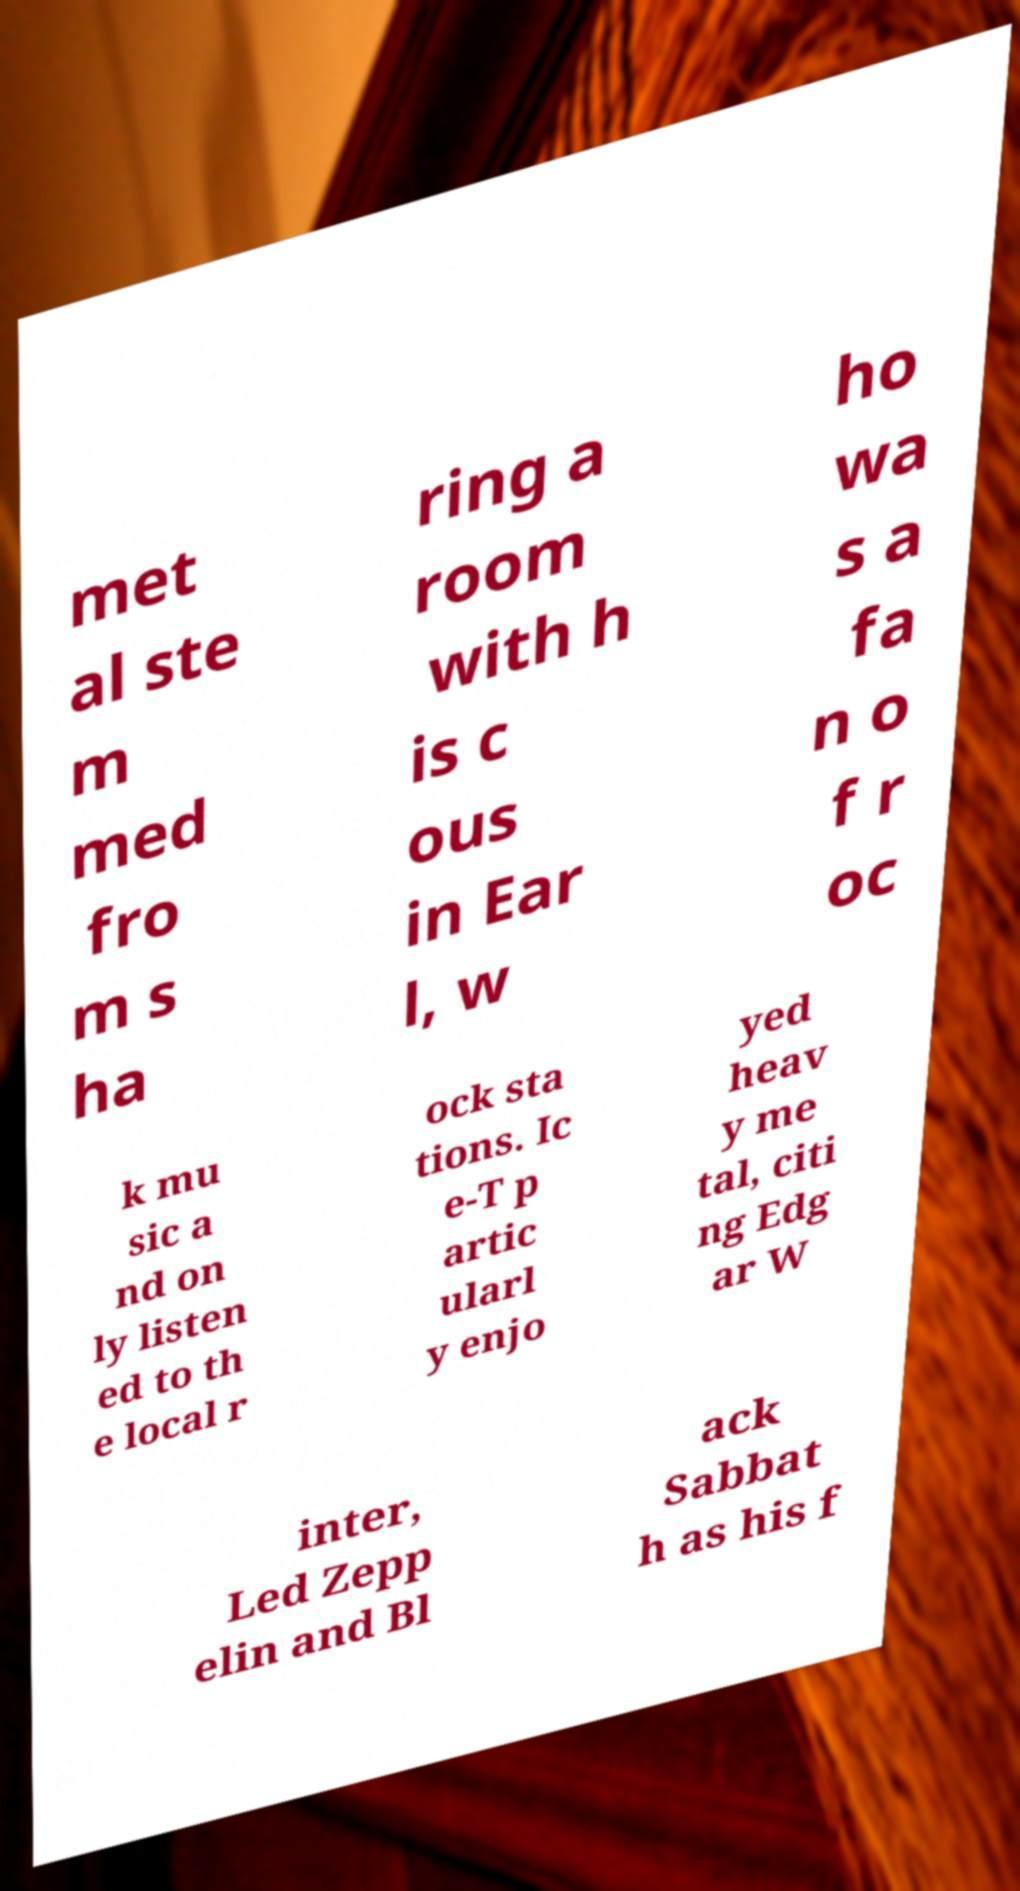Can you read and provide the text displayed in the image?This photo seems to have some interesting text. Can you extract and type it out for me? met al ste m med fro m s ha ring a room with h is c ous in Ear l, w ho wa s a fa n o f r oc k mu sic a nd on ly listen ed to th e local r ock sta tions. Ic e-T p artic ularl y enjo yed heav y me tal, citi ng Edg ar W inter, Led Zepp elin and Bl ack Sabbat h as his f 